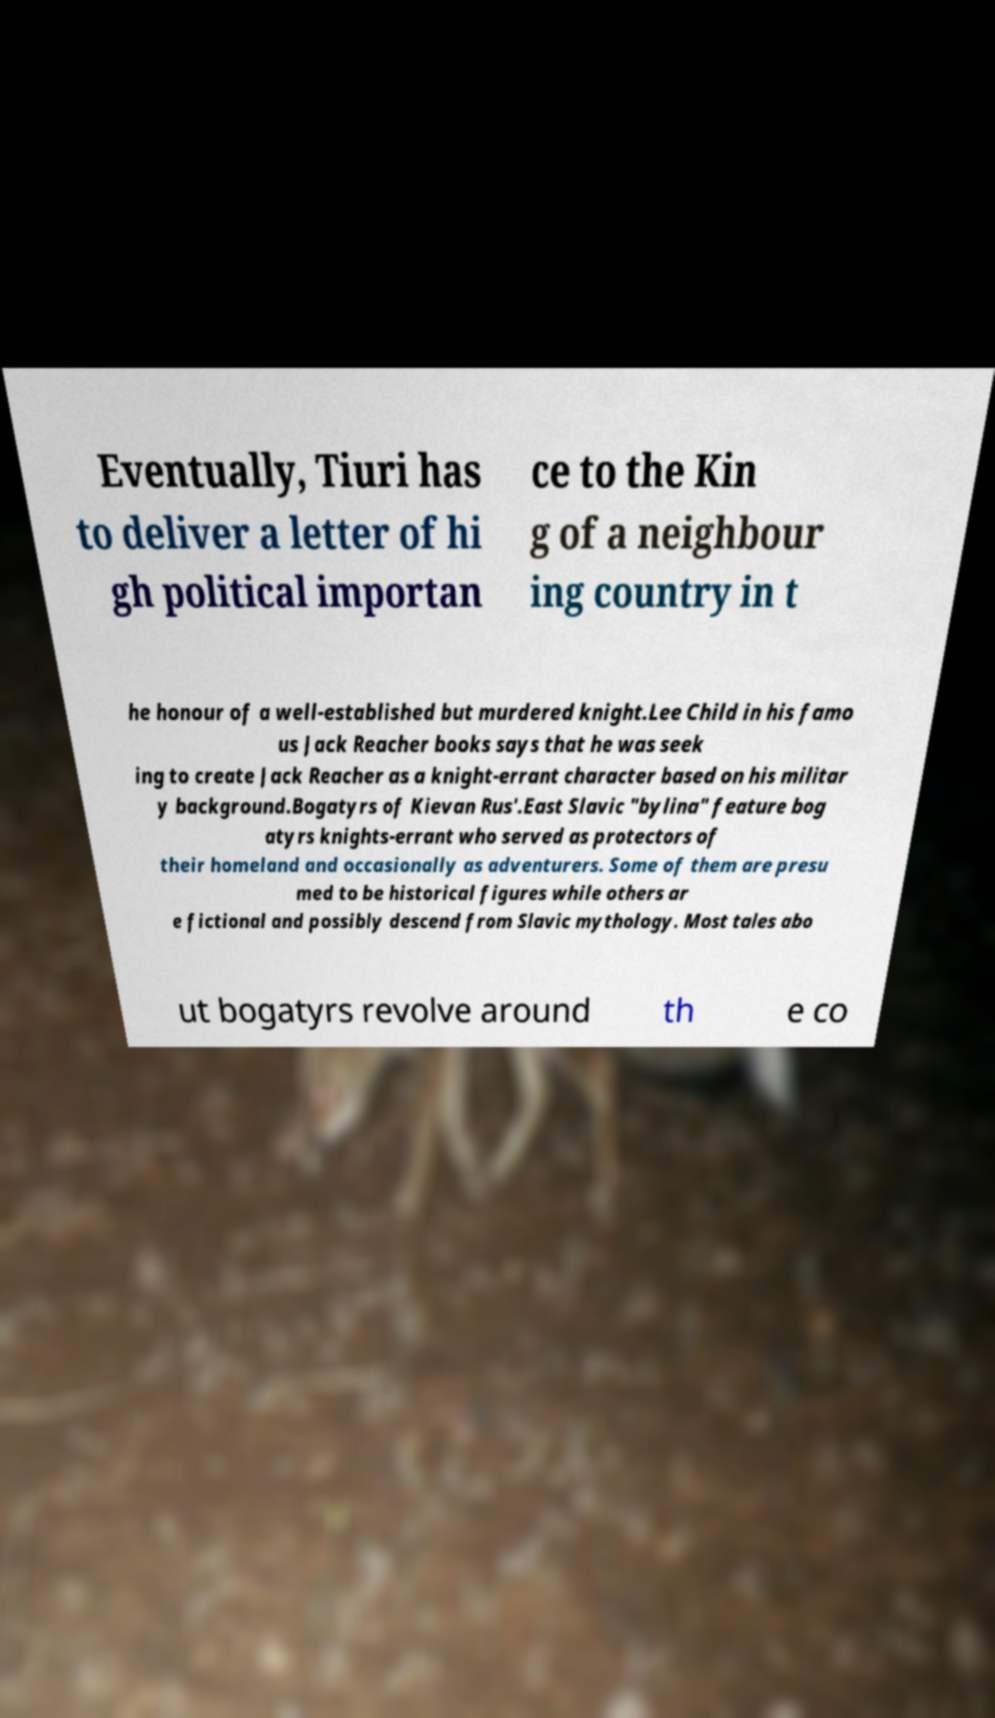Please identify and transcribe the text found in this image. Eventually, Tiuri has to deliver a letter of hi gh political importan ce to the Kin g of a neighbour ing country in t he honour of a well-established but murdered knight.Lee Child in his famo us Jack Reacher books says that he was seek ing to create Jack Reacher as a knight-errant character based on his militar y background.Bogatyrs of Kievan Rus'.East Slavic "bylina" feature bog atyrs knights-errant who served as protectors of their homeland and occasionally as adventurers. Some of them are presu med to be historical figures while others ar e fictional and possibly descend from Slavic mythology. Most tales abo ut bogatyrs revolve around th e co 